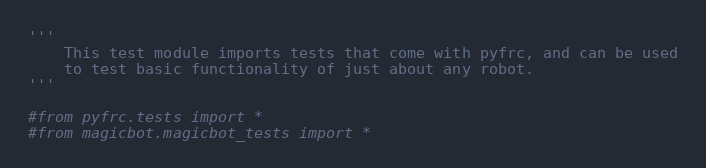<code> <loc_0><loc_0><loc_500><loc_500><_Python_>'''
    This test module imports tests that come with pyfrc, and can be used
    to test basic functionality of just about any robot.
'''

#from pyfrc.tests import *
#from magicbot.magicbot_tests import *
</code> 